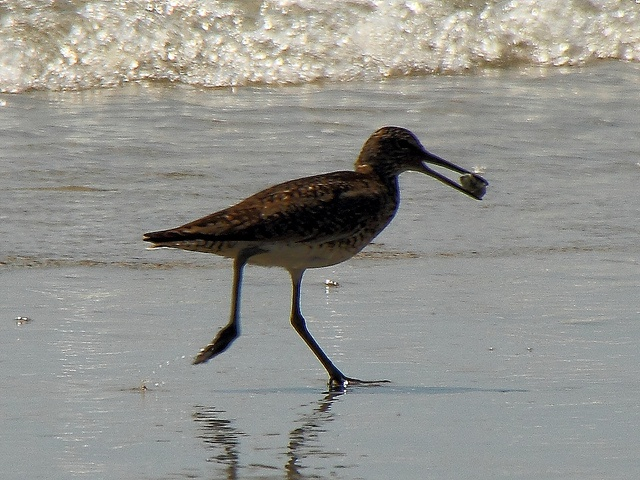Describe the objects in this image and their specific colors. I can see a bird in gray, black, and darkgray tones in this image. 